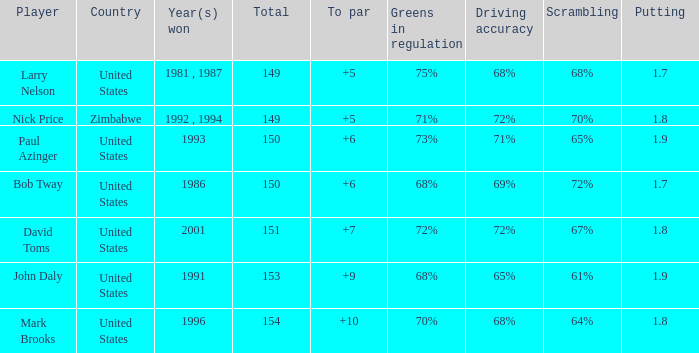How many to pars were won in 1993? 1.0. 